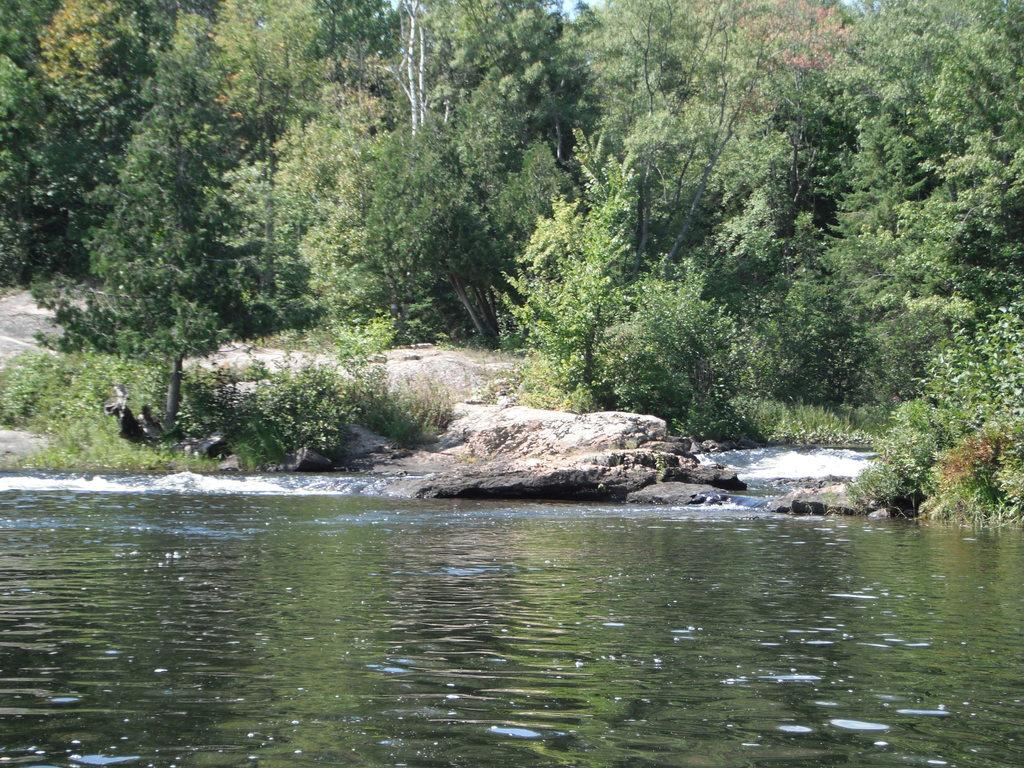What is present in the front of the image? There is water in the front of the image. What other objects or features can be seen in the image? There are rocks and trees in the image. How many points can be seen in the image? There are no points visible in the image. Is there a sea visible in the image? The image does not show a sea; it only shows water, rocks, and trees. 